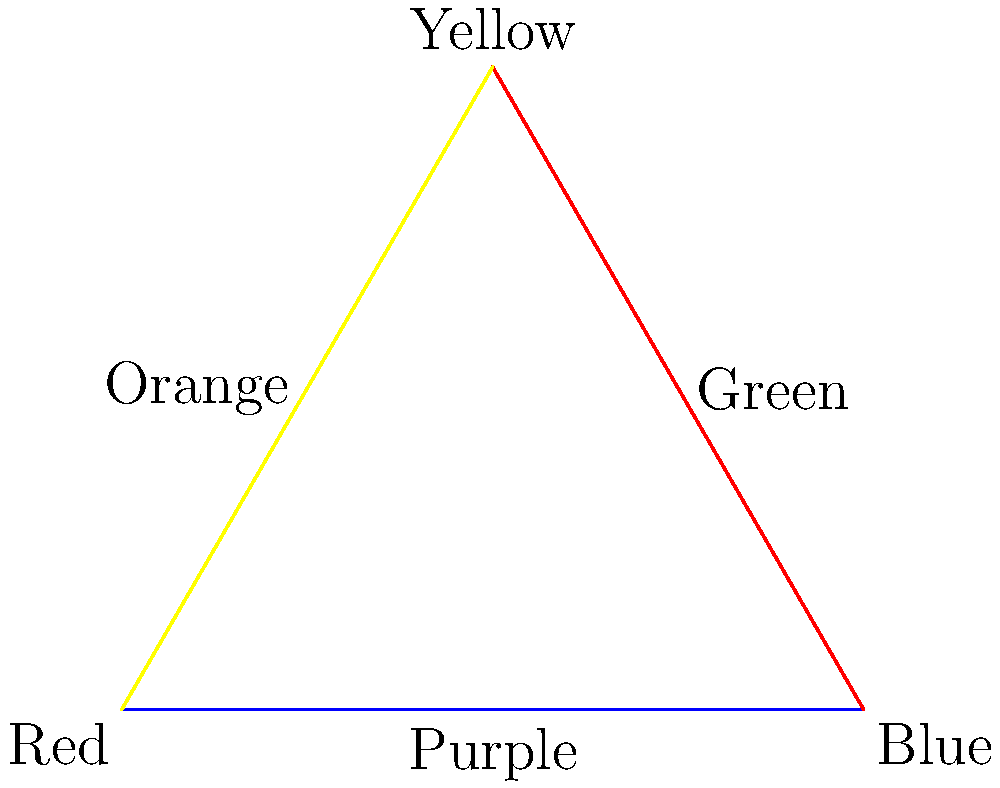In this color mixing graph, primary colors are represented as nodes, and their combinations as edges. If you were to create a painting using only two of these colors, how many unique color palettes could you form? Consider that each palette must include at least one primary color. To solve this problem, let's follow these steps:

1. Identify the primary colors: The graph shows three primary colors as nodes - Red, Blue, and Yellow.

2. Identify the color combinations: The edges represent the secondary colors formed by mixing two primary colors:
   - Red + Blue = Purple
   - Blue + Yellow = Green
   - Yellow + Red = Orange

3. Count the possible color palettes:
   a) Single primary color palettes:
      - Red
      - Blue
      - Yellow
   
   b) Two primary color palettes:
      - Red and Blue
      - Blue and Yellow
      - Yellow and Red
   
   c) Primary color + Secondary color palettes:
      - Red and Purple
      - Red and Orange
      - Blue and Purple
      - Blue and Green
      - Yellow and Green
      - Yellow and Orange

4. Sum up the total number of unique palettes:
   3 (single primary) + 3 (two primaries) + 6 (primary + secondary) = 12

Therefore, you could form 12 unique color palettes using at least one primary color and at most two colors total.
Answer: 12 unique color palettes 